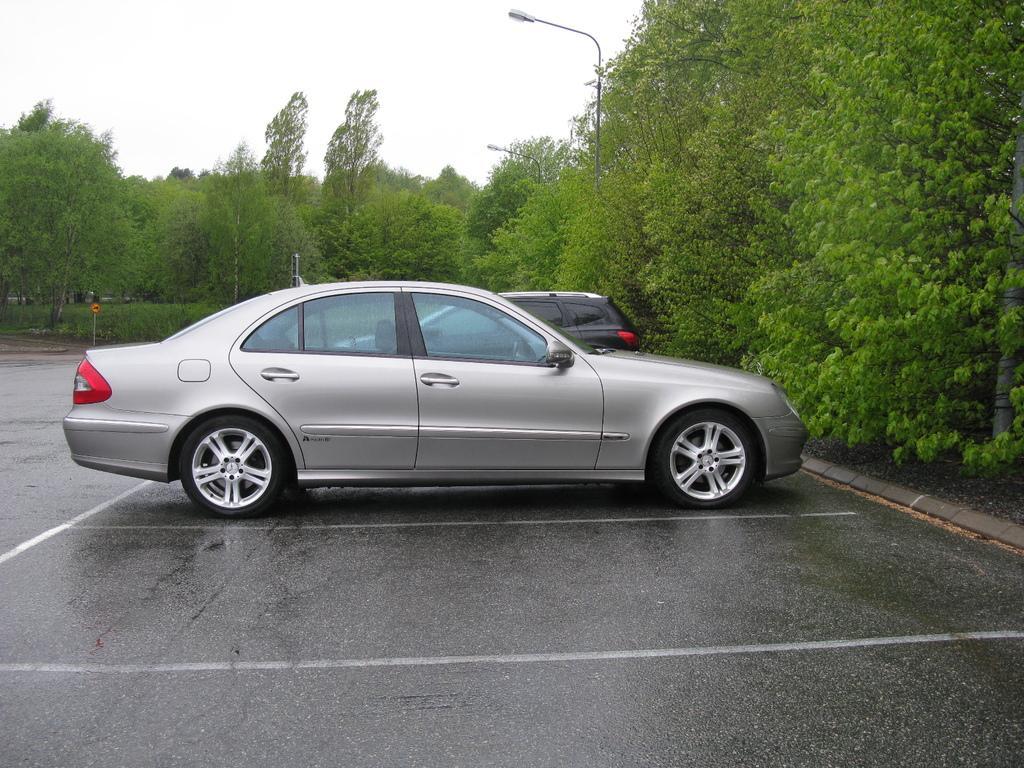Describe this image in one or two sentences. In the center of the picture there are cars. On the right there are trees. At the bottom it is road. In the background we can see street lights, trees, plants, grass, poles and other objects. At the top there is sky. 